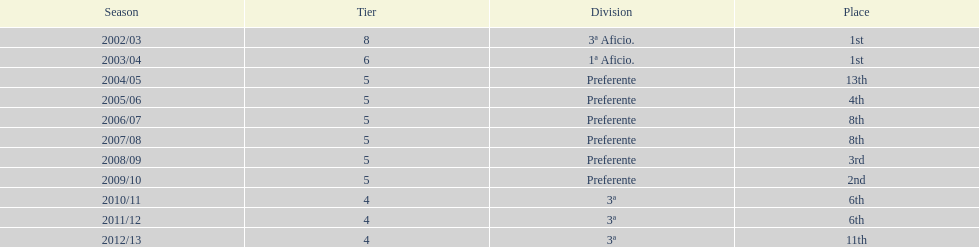Which division placed more than aficio 1a and 3a? Preferente. 